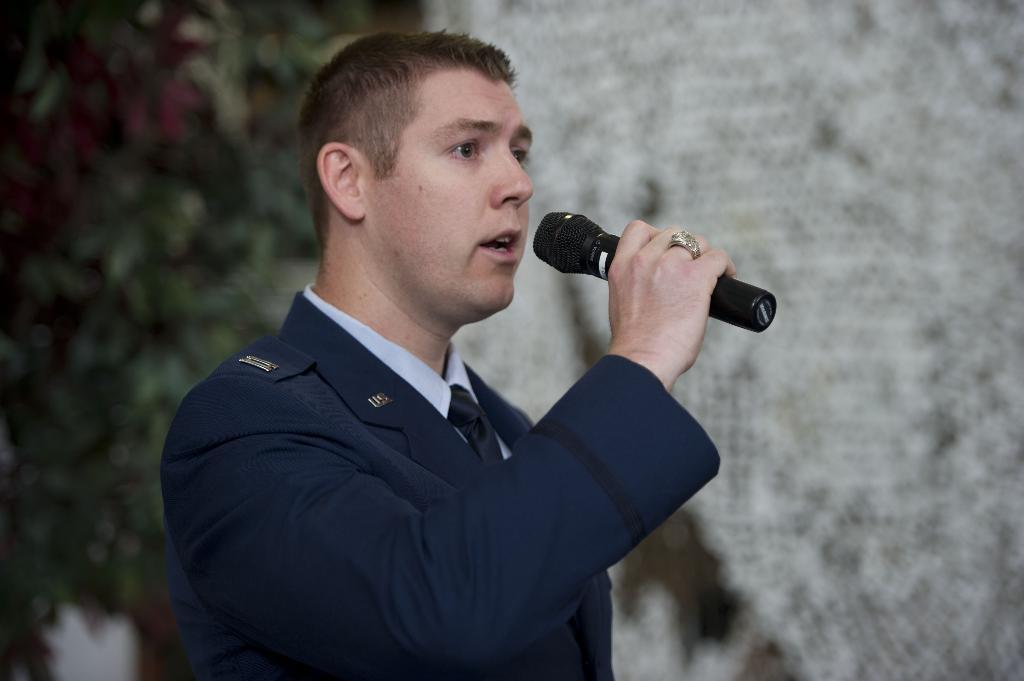What is the man in the image doing? The man is talking into a microphone. What is the man wearing in the image? The man is wearing a coat, tie, and shirt. What can be seen on the left side of the image? There is a plant with leaves on the left side of the image. What type of love can be seen in the image? There is no love present in the image; it features a man talking into a microphone and a plant with leaves. How many balls are visible in the image? There are no balls present in the image. 